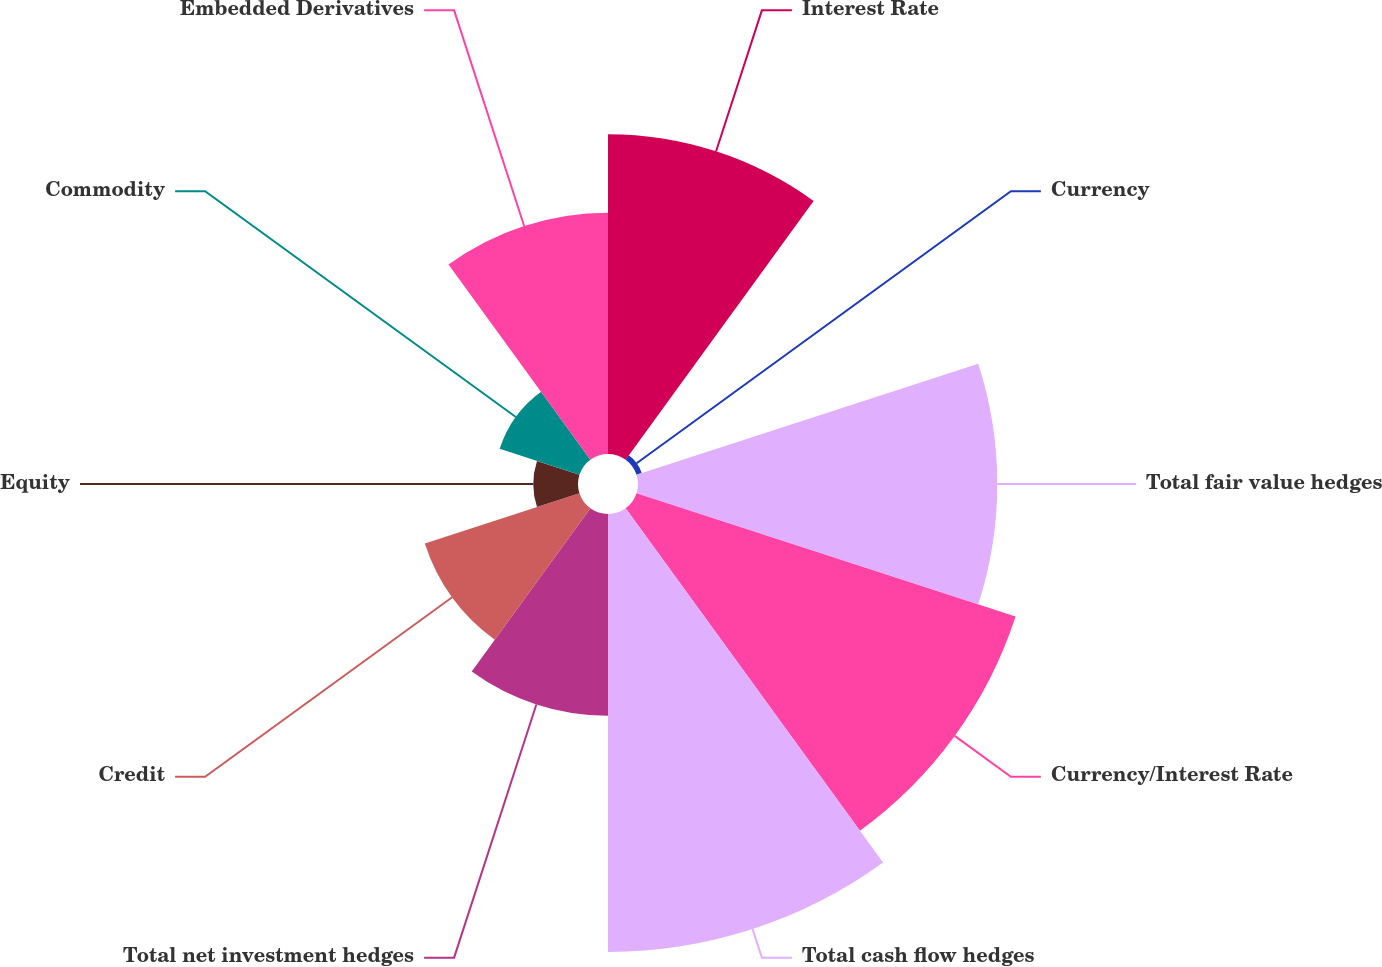Convert chart. <chart><loc_0><loc_0><loc_500><loc_500><pie_chart><fcel>Interest Rate<fcel>Currency<fcel>Total fair value hedges<fcel>Currency/Interest Rate<fcel>Total cash flow hedges<fcel>Total net investment hedges<fcel>Credit<fcel>Equity<fcel>Commodity<fcel>Embedded Derivatives<nl><fcel>14.18%<fcel>0.24%<fcel>15.93%<fcel>17.67%<fcel>19.42%<fcel>8.95%<fcel>7.21%<fcel>1.98%<fcel>3.72%<fcel>10.7%<nl></chart> 